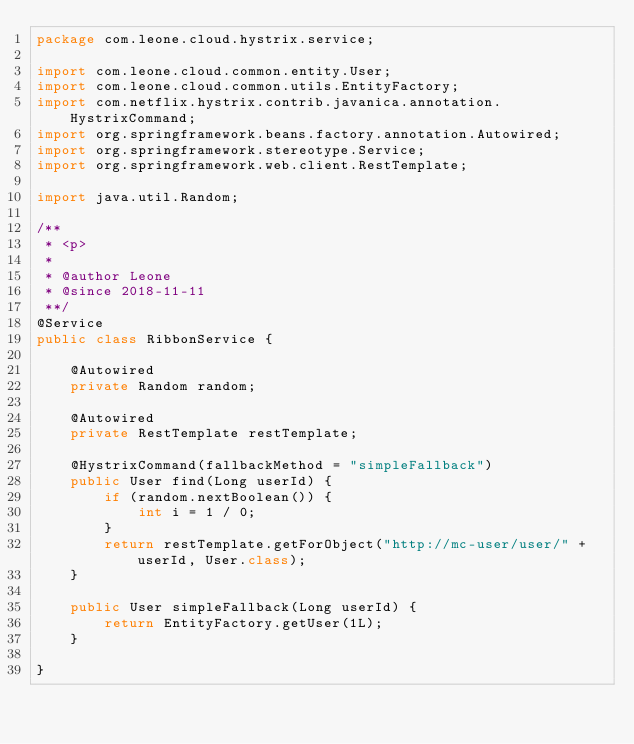Convert code to text. <code><loc_0><loc_0><loc_500><loc_500><_Java_>package com.leone.cloud.hystrix.service;

import com.leone.cloud.common.entity.User;
import com.leone.cloud.common.utils.EntityFactory;
import com.netflix.hystrix.contrib.javanica.annotation.HystrixCommand;
import org.springframework.beans.factory.annotation.Autowired;
import org.springframework.stereotype.Service;
import org.springframework.web.client.RestTemplate;

import java.util.Random;

/**
 * <p>
 *
 * @author Leone
 * @since 2018-11-11
 **/
@Service
public class RibbonService {

    @Autowired
    private Random random;

    @Autowired
    private RestTemplate restTemplate;

    @HystrixCommand(fallbackMethod = "simpleFallback")
    public User find(Long userId) {
        if (random.nextBoolean()) {
            int i = 1 / 0;
        }
        return restTemplate.getForObject("http://mc-user/user/" + userId, User.class);
    }

    public User simpleFallback(Long userId) {
        return EntityFactory.getUser(1L);
    }

}</code> 